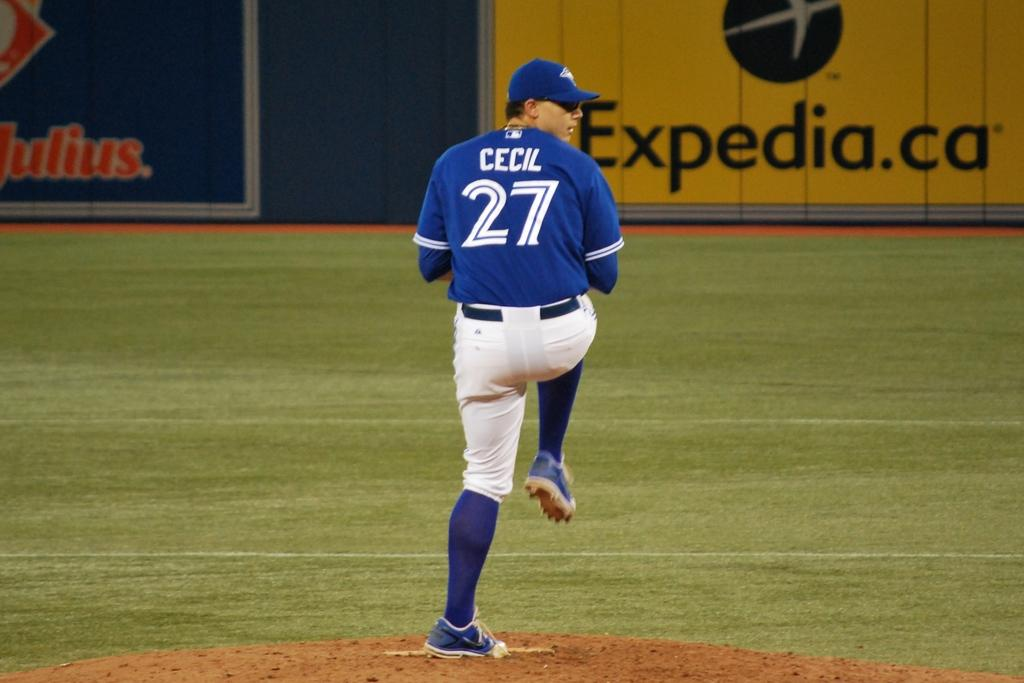<image>
Give a short and clear explanation of the subsequent image. a player that has the name Cecil on their jersey 